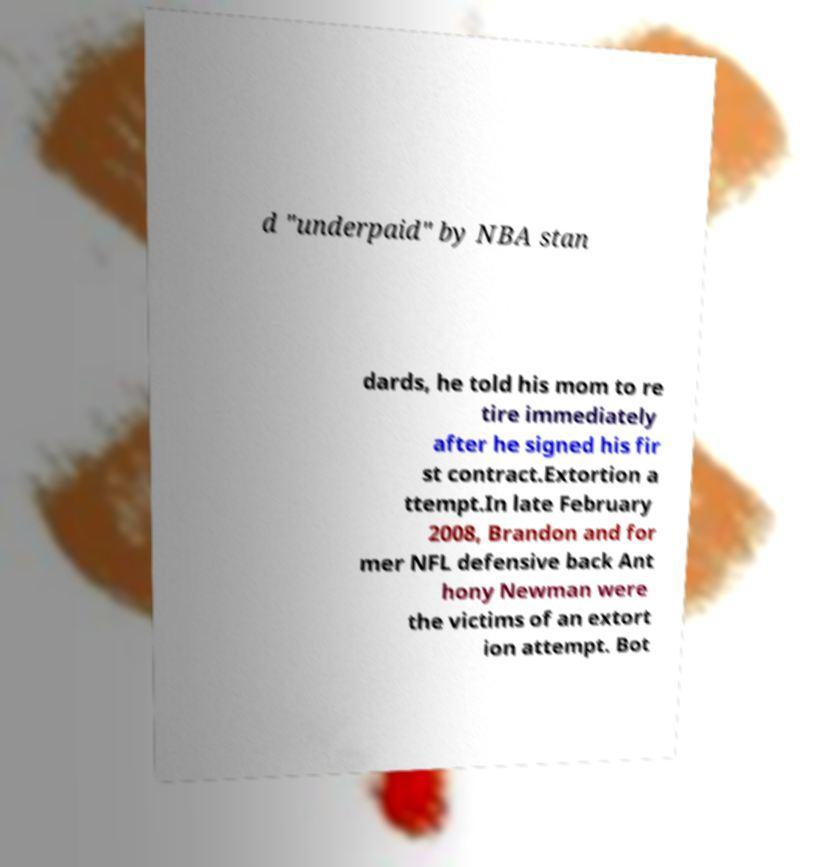What messages or text are displayed in this image? I need them in a readable, typed format. d "underpaid" by NBA stan dards, he told his mom to re tire immediately after he signed his fir st contract.Extortion a ttempt.In late February 2008, Brandon and for mer NFL defensive back Ant hony Newman were the victims of an extort ion attempt. Bot 